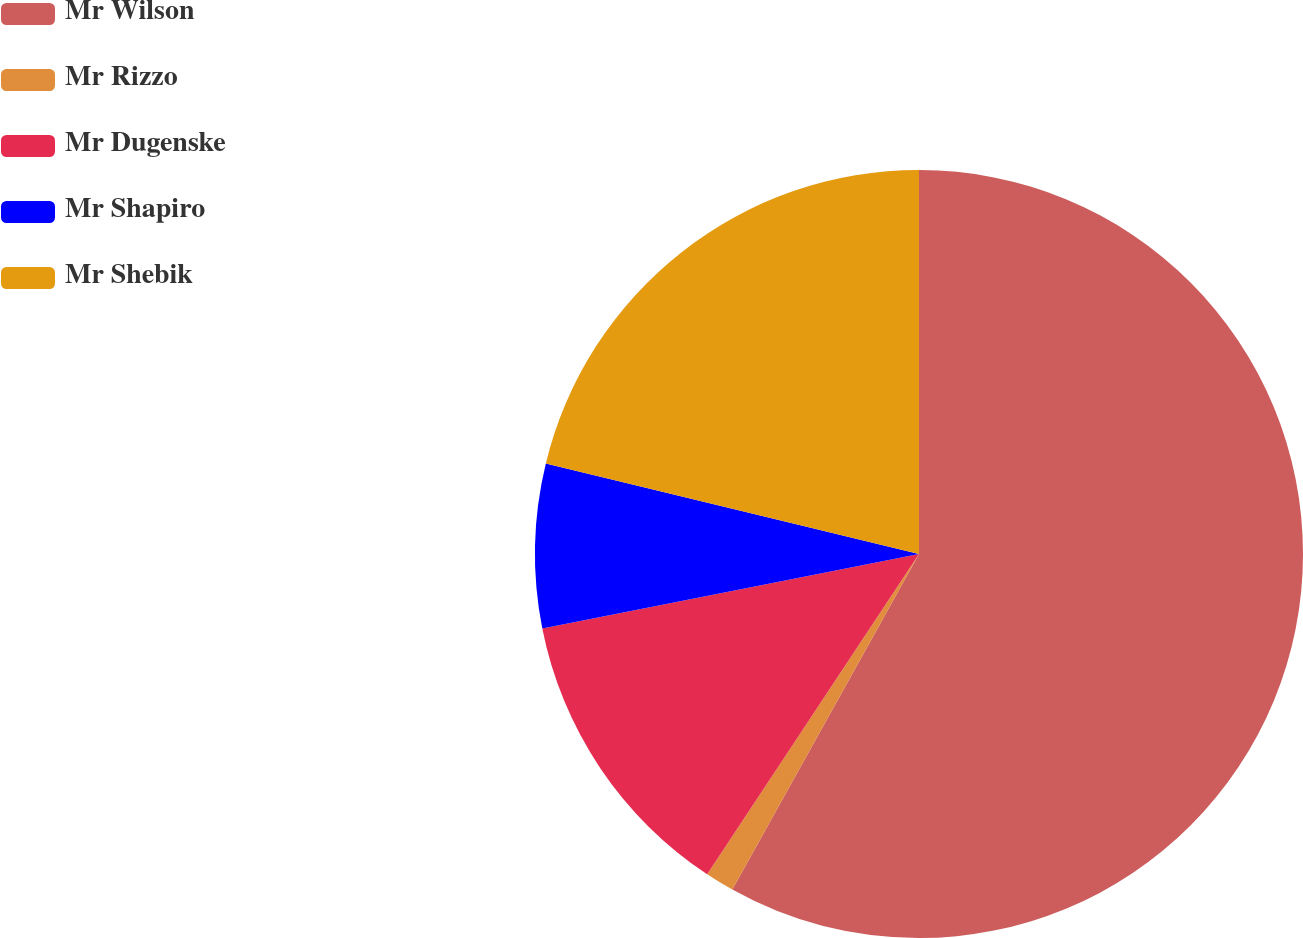<chart> <loc_0><loc_0><loc_500><loc_500><pie_chart><fcel>Mr Wilson<fcel>Mr Rizzo<fcel>Mr Dugenske<fcel>Mr Shapiro<fcel>Mr Shebik<nl><fcel>58.08%<fcel>1.22%<fcel>12.59%<fcel>6.9%<fcel>21.21%<nl></chart> 